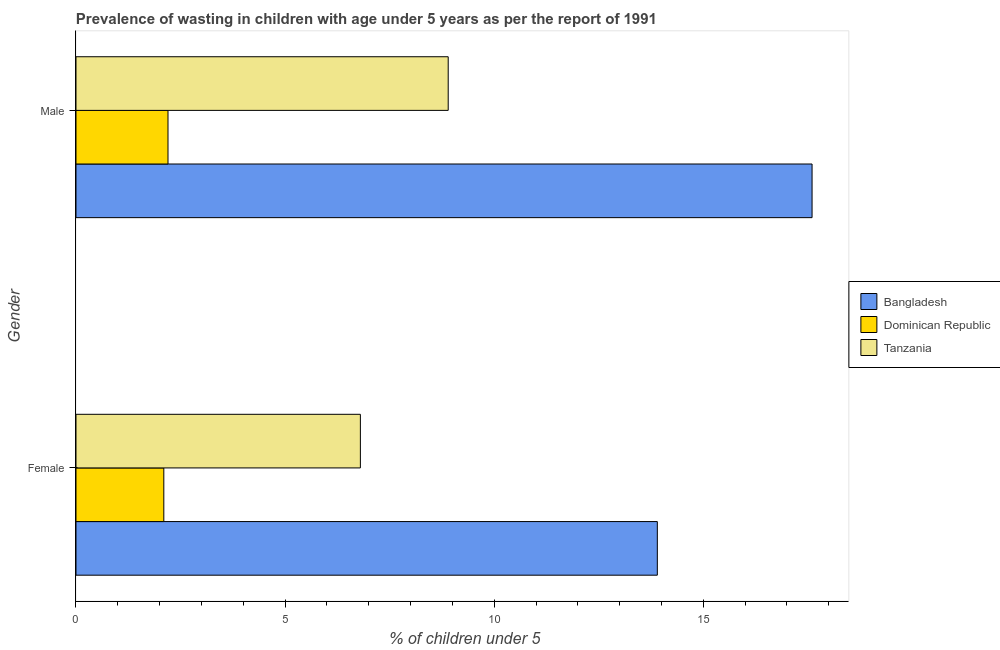Are the number of bars per tick equal to the number of legend labels?
Keep it short and to the point. Yes. Are the number of bars on each tick of the Y-axis equal?
Ensure brevity in your answer.  Yes. How many bars are there on the 1st tick from the top?
Ensure brevity in your answer.  3. How many bars are there on the 1st tick from the bottom?
Provide a short and direct response. 3. What is the label of the 2nd group of bars from the top?
Offer a very short reply. Female. What is the percentage of undernourished male children in Dominican Republic?
Your response must be concise. 2.2. Across all countries, what is the maximum percentage of undernourished male children?
Your answer should be compact. 17.6. Across all countries, what is the minimum percentage of undernourished female children?
Your answer should be compact. 2.1. In which country was the percentage of undernourished male children minimum?
Your answer should be compact. Dominican Republic. What is the total percentage of undernourished male children in the graph?
Keep it short and to the point. 28.7. What is the difference between the percentage of undernourished female children in Dominican Republic and that in Tanzania?
Offer a very short reply. -4.7. What is the difference between the percentage of undernourished male children in Bangladesh and the percentage of undernourished female children in Tanzania?
Offer a terse response. 10.8. What is the average percentage of undernourished female children per country?
Make the answer very short. 7.6. What is the difference between the percentage of undernourished female children and percentage of undernourished male children in Tanzania?
Your answer should be compact. -2.1. What is the ratio of the percentage of undernourished female children in Dominican Republic to that in Tanzania?
Provide a short and direct response. 0.31. What does the 1st bar from the top in Female represents?
Provide a succinct answer. Tanzania. What does the 3rd bar from the bottom in Female represents?
Provide a succinct answer. Tanzania. How many bars are there?
Your answer should be compact. 6. What is the difference between two consecutive major ticks on the X-axis?
Keep it short and to the point. 5. Are the values on the major ticks of X-axis written in scientific E-notation?
Provide a short and direct response. No. Does the graph contain any zero values?
Keep it short and to the point. No. How many legend labels are there?
Your answer should be compact. 3. How are the legend labels stacked?
Offer a very short reply. Vertical. What is the title of the graph?
Give a very brief answer. Prevalence of wasting in children with age under 5 years as per the report of 1991. Does "France" appear as one of the legend labels in the graph?
Offer a terse response. No. What is the label or title of the X-axis?
Ensure brevity in your answer.   % of children under 5. What is the label or title of the Y-axis?
Provide a succinct answer. Gender. What is the  % of children under 5 in Bangladesh in Female?
Offer a very short reply. 13.9. What is the  % of children under 5 in Dominican Republic in Female?
Offer a very short reply. 2.1. What is the  % of children under 5 of Tanzania in Female?
Ensure brevity in your answer.  6.8. What is the  % of children under 5 in Bangladesh in Male?
Provide a succinct answer. 17.6. What is the  % of children under 5 of Dominican Republic in Male?
Your response must be concise. 2.2. What is the  % of children under 5 of Tanzania in Male?
Make the answer very short. 8.9. Across all Gender, what is the maximum  % of children under 5 in Bangladesh?
Provide a short and direct response. 17.6. Across all Gender, what is the maximum  % of children under 5 in Dominican Republic?
Ensure brevity in your answer.  2.2. Across all Gender, what is the maximum  % of children under 5 of Tanzania?
Keep it short and to the point. 8.9. Across all Gender, what is the minimum  % of children under 5 of Bangladesh?
Offer a terse response. 13.9. Across all Gender, what is the minimum  % of children under 5 of Dominican Republic?
Your answer should be very brief. 2.1. Across all Gender, what is the minimum  % of children under 5 of Tanzania?
Your answer should be very brief. 6.8. What is the total  % of children under 5 in Bangladesh in the graph?
Your response must be concise. 31.5. What is the difference between the  % of children under 5 of Tanzania in Female and that in Male?
Keep it short and to the point. -2.1. What is the difference between the  % of children under 5 of Bangladesh in Female and the  % of children under 5 of Dominican Republic in Male?
Give a very brief answer. 11.7. What is the difference between the  % of children under 5 in Dominican Republic in Female and the  % of children under 5 in Tanzania in Male?
Give a very brief answer. -6.8. What is the average  % of children under 5 of Bangladesh per Gender?
Provide a short and direct response. 15.75. What is the average  % of children under 5 of Dominican Republic per Gender?
Give a very brief answer. 2.15. What is the average  % of children under 5 of Tanzania per Gender?
Offer a very short reply. 7.85. What is the difference between the  % of children under 5 in Bangladesh and  % of children under 5 in Dominican Republic in Female?
Give a very brief answer. 11.8. What is the difference between the  % of children under 5 of Bangladesh and  % of children under 5 of Tanzania in Female?
Your answer should be very brief. 7.1. What is the difference between the  % of children under 5 in Bangladesh and  % of children under 5 in Dominican Republic in Male?
Your answer should be very brief. 15.4. What is the difference between the  % of children under 5 of Bangladesh and  % of children under 5 of Tanzania in Male?
Keep it short and to the point. 8.7. What is the ratio of the  % of children under 5 in Bangladesh in Female to that in Male?
Your answer should be compact. 0.79. What is the ratio of the  % of children under 5 in Dominican Republic in Female to that in Male?
Provide a short and direct response. 0.95. What is the ratio of the  % of children under 5 of Tanzania in Female to that in Male?
Provide a short and direct response. 0.76. What is the difference between the highest and the second highest  % of children under 5 in Tanzania?
Make the answer very short. 2.1. What is the difference between the highest and the lowest  % of children under 5 of Tanzania?
Provide a short and direct response. 2.1. 